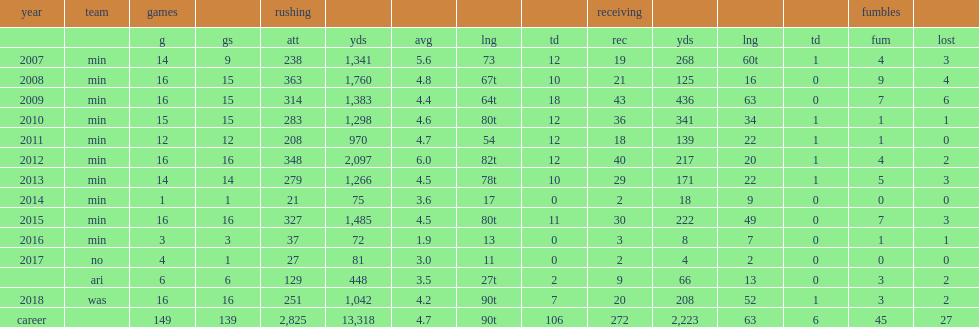I'm looking to parse the entire table for insights. Could you assist me with that? {'header': ['year', 'team', 'games', '', 'rushing', '', '', '', '', 'receiving', '', '', '', 'fumbles', ''], 'rows': [['', '', 'g', 'gs', 'att', 'yds', 'avg', 'lng', 'td', 'rec', 'yds', 'lng', 'td', 'fum', 'lost'], ['2007', 'min', '14', '9', '238', '1,341', '5.6', '73', '12', '19', '268', '60t', '1', '4', '3'], ['2008', 'min', '16', '15', '363', '1,760', '4.8', '67t', '10', '21', '125', '16', '0', '9', '4'], ['2009', 'min', '16', '15', '314', '1,383', '4.4', '64t', '18', '43', '436', '63', '0', '7', '6'], ['2010', 'min', '15', '15', '283', '1,298', '4.6', '80t', '12', '36', '341', '34', '1', '1', '1'], ['2011', 'min', '12', '12', '208', '970', '4.7', '54', '12', '18', '139', '22', '1', '1', '0'], ['2012', 'min', '16', '16', '348', '2,097', '6.0', '82t', '12', '40', '217', '20', '1', '4', '2'], ['2013', 'min', '14', '14', '279', '1,266', '4.5', '78t', '10', '29', '171', '22', '1', '5', '3'], ['2014', 'min', '1', '1', '21', '75', '3.6', '17', '0', '2', '18', '9', '0', '0', '0'], ['2015', 'min', '16', '16', '327', '1,485', '4.5', '80t', '11', '30', '222', '49', '0', '7', '3'], ['2016', 'min', '3', '3', '37', '72', '1.9', '13', '0', '3', '8', '7', '0', '1', '1'], ['2017', 'no', '4', '1', '27', '81', '3.0', '11', '0', '2', '4', '2', '0', '0', '0'], ['', 'ari', '6', '6', '129', '448', '3.5', '27t', '2', '9', '66', '13', '0', '3', '2'], ['2018', 'was', '16', '16', '251', '1,042', '4.2', '90t', '7', '20', '208', '52', '1', '3', '2'], ['career', '', '149', '139', '2,825', '13,318', '4.7', '90t', '106', '272', '2,223', '63', '6', '45', '27']]} How many touchdown did peterson have in 2011. 1.0. 